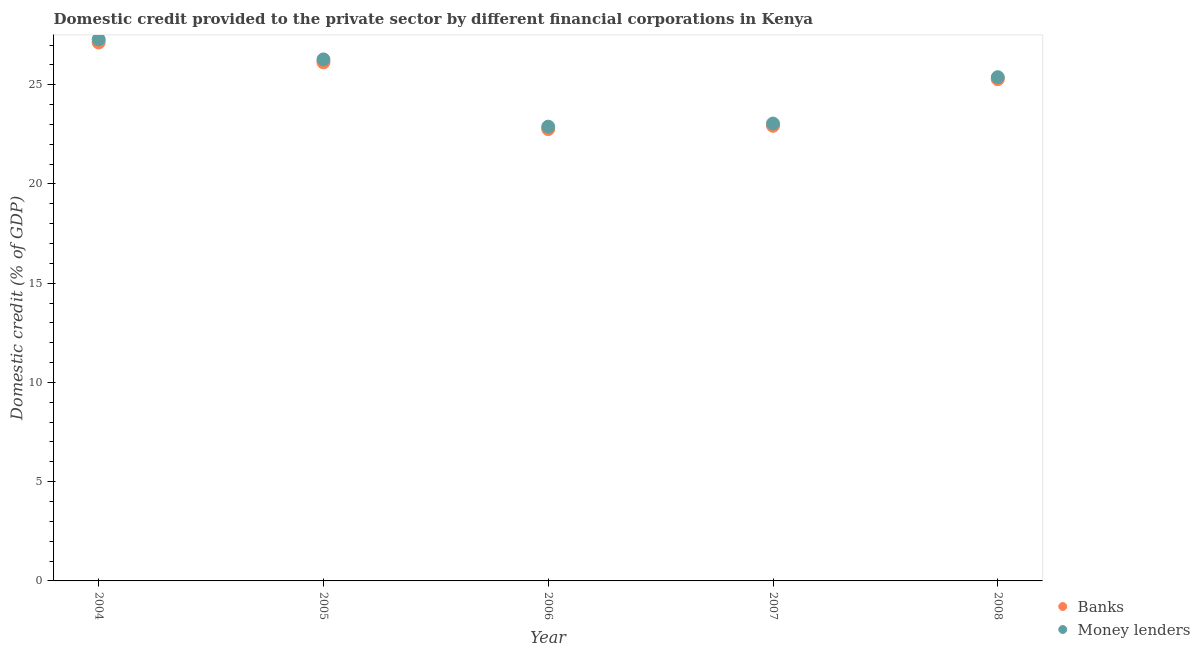How many different coloured dotlines are there?
Make the answer very short. 2. Is the number of dotlines equal to the number of legend labels?
Ensure brevity in your answer.  Yes. What is the domestic credit provided by money lenders in 2005?
Ensure brevity in your answer.  26.28. Across all years, what is the maximum domestic credit provided by money lenders?
Ensure brevity in your answer.  27.29. Across all years, what is the minimum domestic credit provided by money lenders?
Offer a terse response. 22.89. In which year was the domestic credit provided by banks maximum?
Offer a very short reply. 2004. What is the total domestic credit provided by money lenders in the graph?
Your response must be concise. 124.88. What is the difference between the domestic credit provided by banks in 2007 and that in 2008?
Make the answer very short. -2.35. What is the difference between the domestic credit provided by money lenders in 2006 and the domestic credit provided by banks in 2008?
Provide a short and direct response. -2.39. What is the average domestic credit provided by banks per year?
Offer a terse response. 24.85. In the year 2005, what is the difference between the domestic credit provided by money lenders and domestic credit provided by banks?
Keep it short and to the point. 0.15. In how many years, is the domestic credit provided by banks greater than 6 %?
Offer a very short reply. 5. What is the ratio of the domestic credit provided by banks in 2006 to that in 2008?
Provide a succinct answer. 0.9. Is the domestic credit provided by banks in 2004 less than that in 2005?
Your answer should be very brief. No. Is the difference between the domestic credit provided by money lenders in 2007 and 2008 greater than the difference between the domestic credit provided by banks in 2007 and 2008?
Provide a short and direct response. Yes. What is the difference between the highest and the second highest domestic credit provided by banks?
Your answer should be very brief. 1. What is the difference between the highest and the lowest domestic credit provided by banks?
Give a very brief answer. 4.36. In how many years, is the domestic credit provided by banks greater than the average domestic credit provided by banks taken over all years?
Make the answer very short. 3. Is the sum of the domestic credit provided by money lenders in 2005 and 2007 greater than the maximum domestic credit provided by banks across all years?
Give a very brief answer. Yes. How many dotlines are there?
Your answer should be compact. 2. Are the values on the major ticks of Y-axis written in scientific E-notation?
Keep it short and to the point. No. Does the graph contain any zero values?
Make the answer very short. No. Does the graph contain grids?
Your answer should be very brief. No. Where does the legend appear in the graph?
Your answer should be compact. Bottom right. How many legend labels are there?
Offer a very short reply. 2. How are the legend labels stacked?
Keep it short and to the point. Vertical. What is the title of the graph?
Offer a very short reply. Domestic credit provided to the private sector by different financial corporations in Kenya. Does "Death rate" appear as one of the legend labels in the graph?
Offer a terse response. No. What is the label or title of the Y-axis?
Provide a succinct answer. Domestic credit (% of GDP). What is the Domestic credit (% of GDP) in Banks in 2004?
Offer a very short reply. 27.13. What is the Domestic credit (% of GDP) of Money lenders in 2004?
Provide a short and direct response. 27.29. What is the Domestic credit (% of GDP) in Banks in 2005?
Offer a terse response. 26.13. What is the Domestic credit (% of GDP) in Money lenders in 2005?
Your response must be concise. 26.28. What is the Domestic credit (% of GDP) in Banks in 2006?
Keep it short and to the point. 22.77. What is the Domestic credit (% of GDP) in Money lenders in 2006?
Offer a terse response. 22.89. What is the Domestic credit (% of GDP) in Banks in 2007?
Make the answer very short. 22.93. What is the Domestic credit (% of GDP) in Money lenders in 2007?
Make the answer very short. 23.04. What is the Domestic credit (% of GDP) in Banks in 2008?
Ensure brevity in your answer.  25.28. What is the Domestic credit (% of GDP) in Money lenders in 2008?
Offer a very short reply. 25.38. Across all years, what is the maximum Domestic credit (% of GDP) of Banks?
Give a very brief answer. 27.13. Across all years, what is the maximum Domestic credit (% of GDP) in Money lenders?
Provide a succinct answer. 27.29. Across all years, what is the minimum Domestic credit (% of GDP) of Banks?
Give a very brief answer. 22.77. Across all years, what is the minimum Domestic credit (% of GDP) in Money lenders?
Provide a short and direct response. 22.89. What is the total Domestic credit (% of GDP) in Banks in the graph?
Offer a very short reply. 124.25. What is the total Domestic credit (% of GDP) in Money lenders in the graph?
Provide a short and direct response. 124.88. What is the difference between the Domestic credit (% of GDP) in Banks in 2004 and that in 2005?
Ensure brevity in your answer.  1. What is the difference between the Domestic credit (% of GDP) in Money lenders in 2004 and that in 2005?
Give a very brief answer. 1.01. What is the difference between the Domestic credit (% of GDP) of Banks in 2004 and that in 2006?
Give a very brief answer. 4.36. What is the difference between the Domestic credit (% of GDP) of Money lenders in 2004 and that in 2006?
Offer a very short reply. 4.4. What is the difference between the Domestic credit (% of GDP) in Banks in 2004 and that in 2007?
Offer a very short reply. 4.2. What is the difference between the Domestic credit (% of GDP) in Money lenders in 2004 and that in 2007?
Keep it short and to the point. 4.24. What is the difference between the Domestic credit (% of GDP) of Banks in 2004 and that in 2008?
Provide a short and direct response. 1.85. What is the difference between the Domestic credit (% of GDP) in Money lenders in 2004 and that in 2008?
Provide a succinct answer. 1.91. What is the difference between the Domestic credit (% of GDP) in Banks in 2005 and that in 2006?
Your answer should be very brief. 3.36. What is the difference between the Domestic credit (% of GDP) of Money lenders in 2005 and that in 2006?
Provide a succinct answer. 3.39. What is the difference between the Domestic credit (% of GDP) in Banks in 2005 and that in 2007?
Your response must be concise. 3.2. What is the difference between the Domestic credit (% of GDP) in Money lenders in 2005 and that in 2007?
Keep it short and to the point. 3.23. What is the difference between the Domestic credit (% of GDP) of Banks in 2005 and that in 2008?
Keep it short and to the point. 0.85. What is the difference between the Domestic credit (% of GDP) in Money lenders in 2005 and that in 2008?
Offer a very short reply. 0.9. What is the difference between the Domestic credit (% of GDP) in Banks in 2006 and that in 2007?
Your response must be concise. -0.17. What is the difference between the Domestic credit (% of GDP) in Money lenders in 2006 and that in 2007?
Offer a terse response. -0.16. What is the difference between the Domestic credit (% of GDP) in Banks in 2006 and that in 2008?
Give a very brief answer. -2.51. What is the difference between the Domestic credit (% of GDP) of Money lenders in 2006 and that in 2008?
Provide a short and direct response. -2.49. What is the difference between the Domestic credit (% of GDP) in Banks in 2007 and that in 2008?
Your answer should be compact. -2.35. What is the difference between the Domestic credit (% of GDP) in Money lenders in 2007 and that in 2008?
Keep it short and to the point. -2.34. What is the difference between the Domestic credit (% of GDP) of Banks in 2004 and the Domestic credit (% of GDP) of Money lenders in 2005?
Offer a very short reply. 0.85. What is the difference between the Domestic credit (% of GDP) in Banks in 2004 and the Domestic credit (% of GDP) in Money lenders in 2006?
Offer a very short reply. 4.24. What is the difference between the Domestic credit (% of GDP) in Banks in 2004 and the Domestic credit (% of GDP) in Money lenders in 2007?
Provide a succinct answer. 4.09. What is the difference between the Domestic credit (% of GDP) in Banks in 2004 and the Domestic credit (% of GDP) in Money lenders in 2008?
Give a very brief answer. 1.75. What is the difference between the Domestic credit (% of GDP) in Banks in 2005 and the Domestic credit (% of GDP) in Money lenders in 2006?
Ensure brevity in your answer.  3.24. What is the difference between the Domestic credit (% of GDP) of Banks in 2005 and the Domestic credit (% of GDP) of Money lenders in 2007?
Provide a succinct answer. 3.09. What is the difference between the Domestic credit (% of GDP) in Banks in 2005 and the Domestic credit (% of GDP) in Money lenders in 2008?
Keep it short and to the point. 0.75. What is the difference between the Domestic credit (% of GDP) in Banks in 2006 and the Domestic credit (% of GDP) in Money lenders in 2007?
Provide a succinct answer. -0.28. What is the difference between the Domestic credit (% of GDP) in Banks in 2006 and the Domestic credit (% of GDP) in Money lenders in 2008?
Provide a short and direct response. -2.61. What is the difference between the Domestic credit (% of GDP) in Banks in 2007 and the Domestic credit (% of GDP) in Money lenders in 2008?
Your answer should be compact. -2.45. What is the average Domestic credit (% of GDP) in Banks per year?
Give a very brief answer. 24.85. What is the average Domestic credit (% of GDP) of Money lenders per year?
Your response must be concise. 24.98. In the year 2004, what is the difference between the Domestic credit (% of GDP) in Banks and Domestic credit (% of GDP) in Money lenders?
Ensure brevity in your answer.  -0.16. In the year 2005, what is the difference between the Domestic credit (% of GDP) of Banks and Domestic credit (% of GDP) of Money lenders?
Your answer should be very brief. -0.15. In the year 2006, what is the difference between the Domestic credit (% of GDP) of Banks and Domestic credit (% of GDP) of Money lenders?
Ensure brevity in your answer.  -0.12. In the year 2007, what is the difference between the Domestic credit (% of GDP) of Banks and Domestic credit (% of GDP) of Money lenders?
Make the answer very short. -0.11. In the year 2008, what is the difference between the Domestic credit (% of GDP) of Banks and Domestic credit (% of GDP) of Money lenders?
Provide a short and direct response. -0.1. What is the ratio of the Domestic credit (% of GDP) of Banks in 2004 to that in 2005?
Your answer should be compact. 1.04. What is the ratio of the Domestic credit (% of GDP) of Money lenders in 2004 to that in 2005?
Keep it short and to the point. 1.04. What is the ratio of the Domestic credit (% of GDP) of Banks in 2004 to that in 2006?
Provide a succinct answer. 1.19. What is the ratio of the Domestic credit (% of GDP) in Money lenders in 2004 to that in 2006?
Your response must be concise. 1.19. What is the ratio of the Domestic credit (% of GDP) in Banks in 2004 to that in 2007?
Give a very brief answer. 1.18. What is the ratio of the Domestic credit (% of GDP) of Money lenders in 2004 to that in 2007?
Provide a succinct answer. 1.18. What is the ratio of the Domestic credit (% of GDP) in Banks in 2004 to that in 2008?
Offer a terse response. 1.07. What is the ratio of the Domestic credit (% of GDP) in Money lenders in 2004 to that in 2008?
Provide a short and direct response. 1.08. What is the ratio of the Domestic credit (% of GDP) in Banks in 2005 to that in 2006?
Provide a short and direct response. 1.15. What is the ratio of the Domestic credit (% of GDP) in Money lenders in 2005 to that in 2006?
Offer a terse response. 1.15. What is the ratio of the Domestic credit (% of GDP) of Banks in 2005 to that in 2007?
Provide a short and direct response. 1.14. What is the ratio of the Domestic credit (% of GDP) in Money lenders in 2005 to that in 2007?
Your answer should be compact. 1.14. What is the ratio of the Domestic credit (% of GDP) of Banks in 2005 to that in 2008?
Your answer should be very brief. 1.03. What is the ratio of the Domestic credit (% of GDP) of Money lenders in 2005 to that in 2008?
Provide a short and direct response. 1.04. What is the ratio of the Domestic credit (% of GDP) in Banks in 2006 to that in 2007?
Make the answer very short. 0.99. What is the ratio of the Domestic credit (% of GDP) in Money lenders in 2006 to that in 2007?
Make the answer very short. 0.99. What is the ratio of the Domestic credit (% of GDP) of Banks in 2006 to that in 2008?
Offer a very short reply. 0.9. What is the ratio of the Domestic credit (% of GDP) in Money lenders in 2006 to that in 2008?
Offer a very short reply. 0.9. What is the ratio of the Domestic credit (% of GDP) of Banks in 2007 to that in 2008?
Your answer should be compact. 0.91. What is the ratio of the Domestic credit (% of GDP) of Money lenders in 2007 to that in 2008?
Ensure brevity in your answer.  0.91. What is the difference between the highest and the second highest Domestic credit (% of GDP) of Banks?
Provide a short and direct response. 1. What is the difference between the highest and the second highest Domestic credit (% of GDP) in Money lenders?
Your response must be concise. 1.01. What is the difference between the highest and the lowest Domestic credit (% of GDP) of Banks?
Your answer should be compact. 4.36. What is the difference between the highest and the lowest Domestic credit (% of GDP) in Money lenders?
Ensure brevity in your answer.  4.4. 